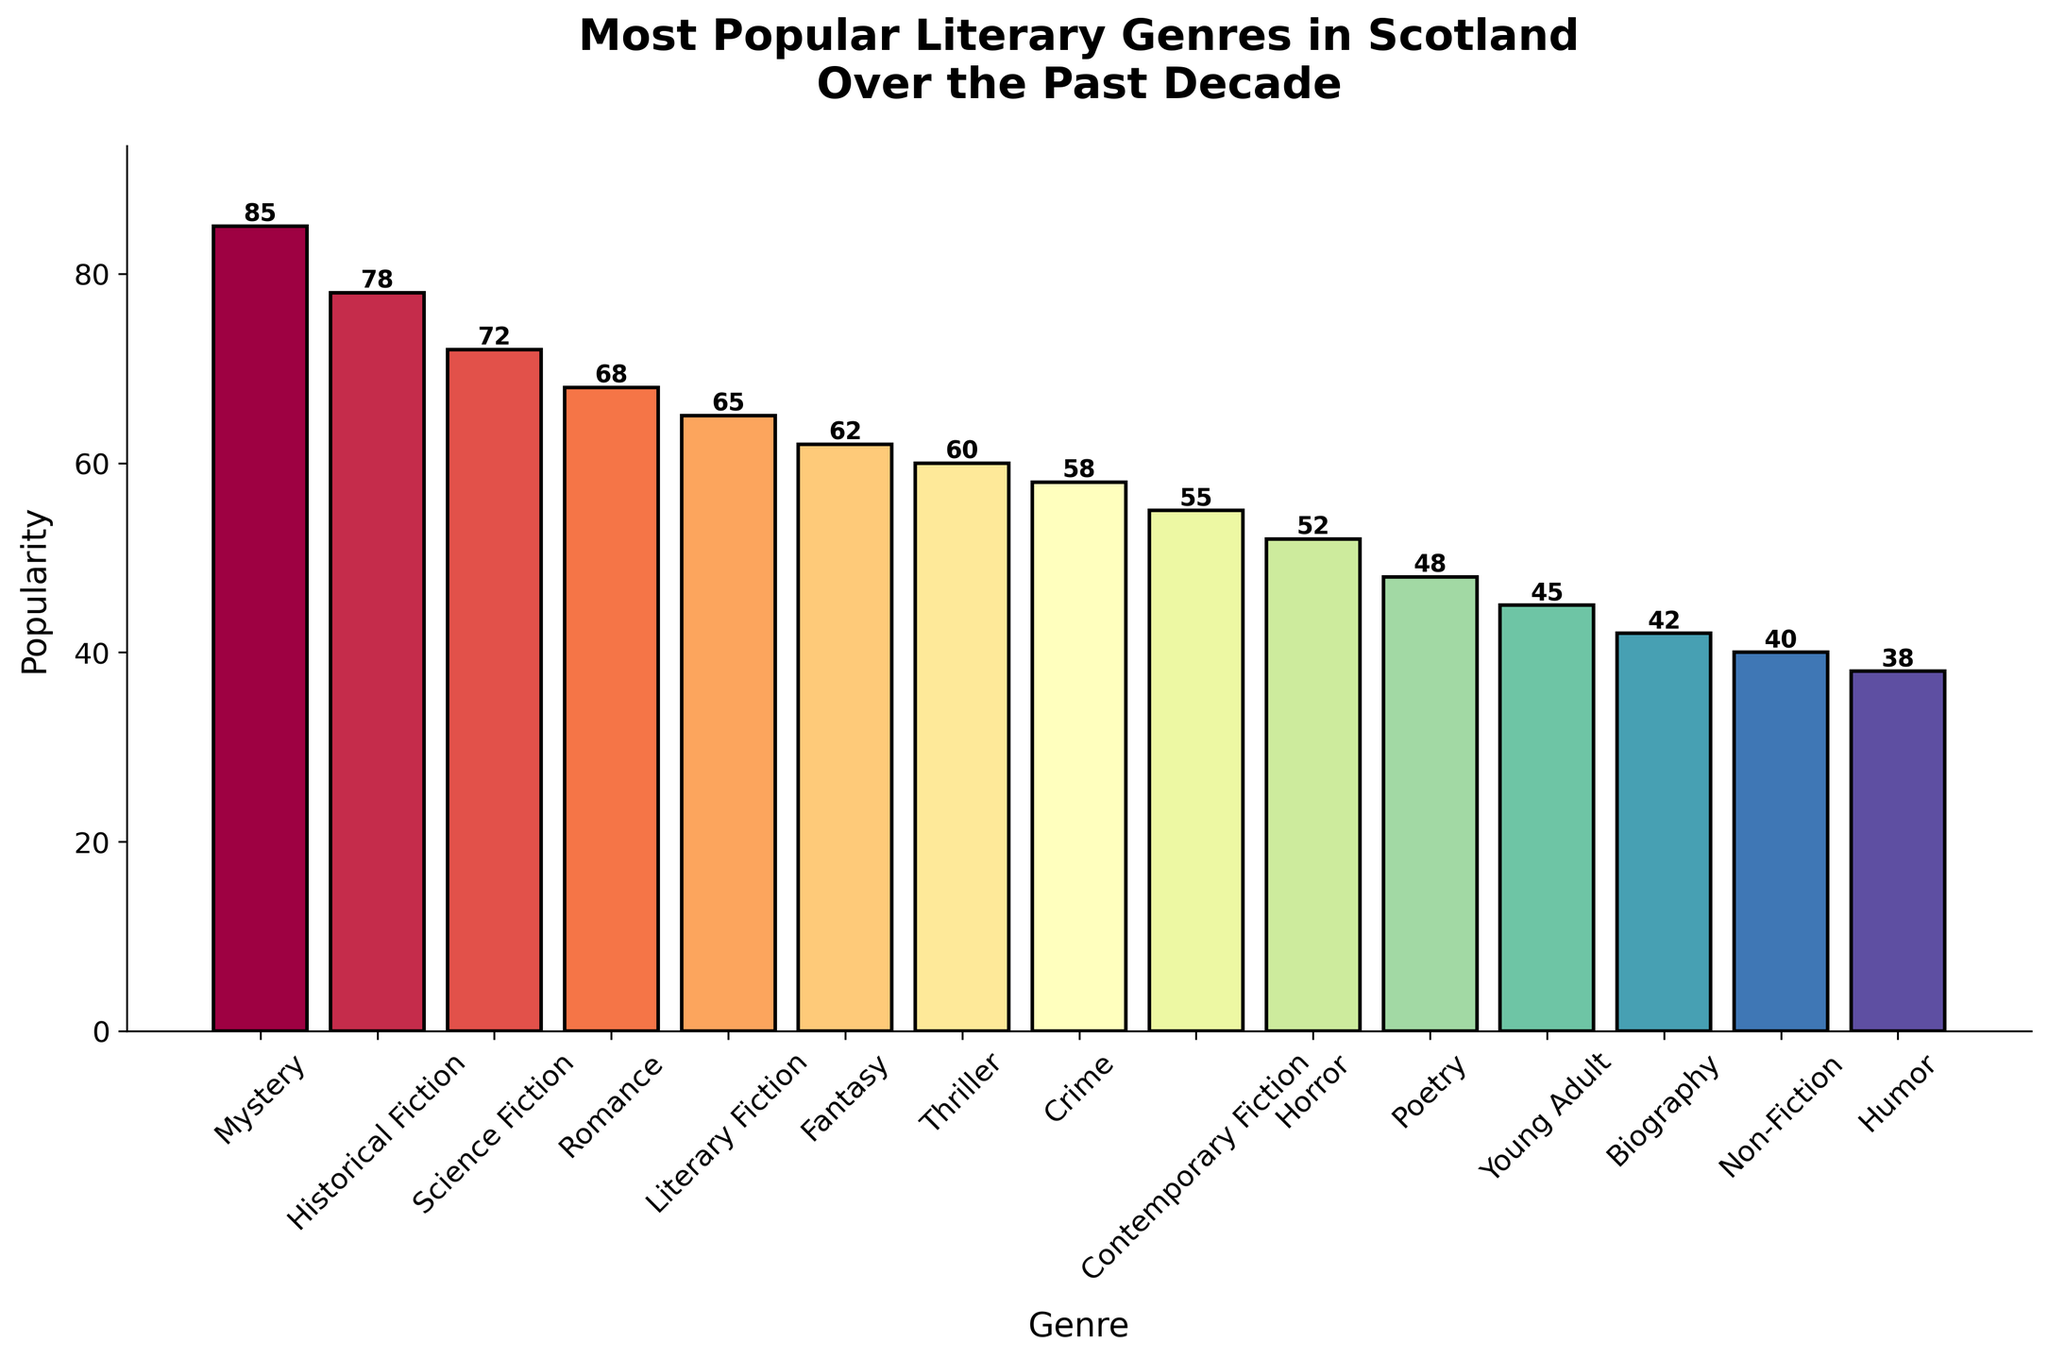What's the most popular literary genre in Scotland over the past decade? To find the most popular genre, look for the tallest bar in the bar chart, which represents the highest popularity value. The tallest bar corresponds to "Mystery" with a popularity of 85.
Answer: Mystery Which genre has a higher popularity, Romance or Biography? Compare the heights of the bars for Romance and Biography. The bar for Romance is higher with a popularity of 68, while Biography has a lower popularity of 42.
Answer: Romance What is the combined popularity of Science Fiction, Fantasy, and Horror genres? Add the popularity values of Science Fiction (72), Fantasy (62), and Horror (52). The total is 72 + 62 + 52 = 186.
Answer: 186 Which genres have a popularity less than 50? Identify the bars with heights indicating popularity below 50. These genres are Poetry (48), Young Adult (45), Biography (42), Non-Fiction (40), and Humor (38).
Answer: Poetry, Young Adult, Biography, Non-Fiction, Humor Does Contemporary Fiction have a higher popularity than Thriller? Compare the heights of the bars for Contemporary Fiction and Thriller. Contemporary Fiction has a popularity of 55, while Thriller has 60, indicating that Thriller is more popular.
Answer: No What is the difference in popularity between the most and least popular genres? Subtract the popularity of the least popular genre (Humor, 38) from the most popular genre (Mystery, 85). The difference is 85 - 38 = 47.
Answer: 47 Which genre is closest in popularity to Historical Fiction? Look for the bar that has a height close to Historical Fiction (78). The closest genre by popularity is Science Fiction with 72.
Answer: Science Fiction What is the average popularity of the given genres? Sum up all the popularity values and divide by the number of genres. The sum is 921 and there are 15 genres, so the average is 921 / 15 = 61.4.
Answer: 61.4 Is there a genre with exactly 10 units more popularity than Horror? Horror has a popularity of 52. Add 10 to get 62. The genre with a popularity of 62 is Fantasy.
Answer: Yes, Fantasy What is the median popularity value of all genres? Arrange the popularity values in ascending order and find the middle value. The values are: 38, 40, 42, 45, 48, 52, 55, 58, 60, 62, 65, 68, 72, 78, 85. The median is the 8th value, which is 58.
Answer: 58 